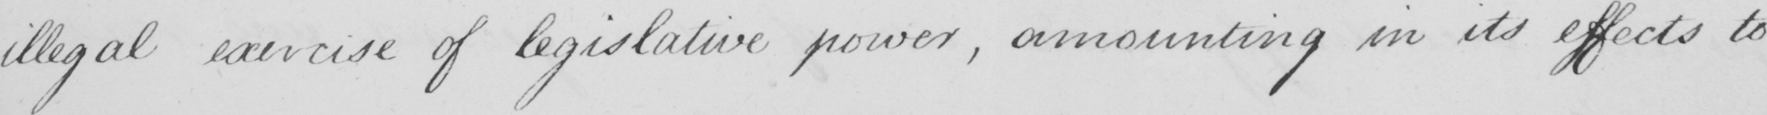Transcribe the text shown in this historical manuscript line. illegal exercise of legislative power , amounting in its effects to 